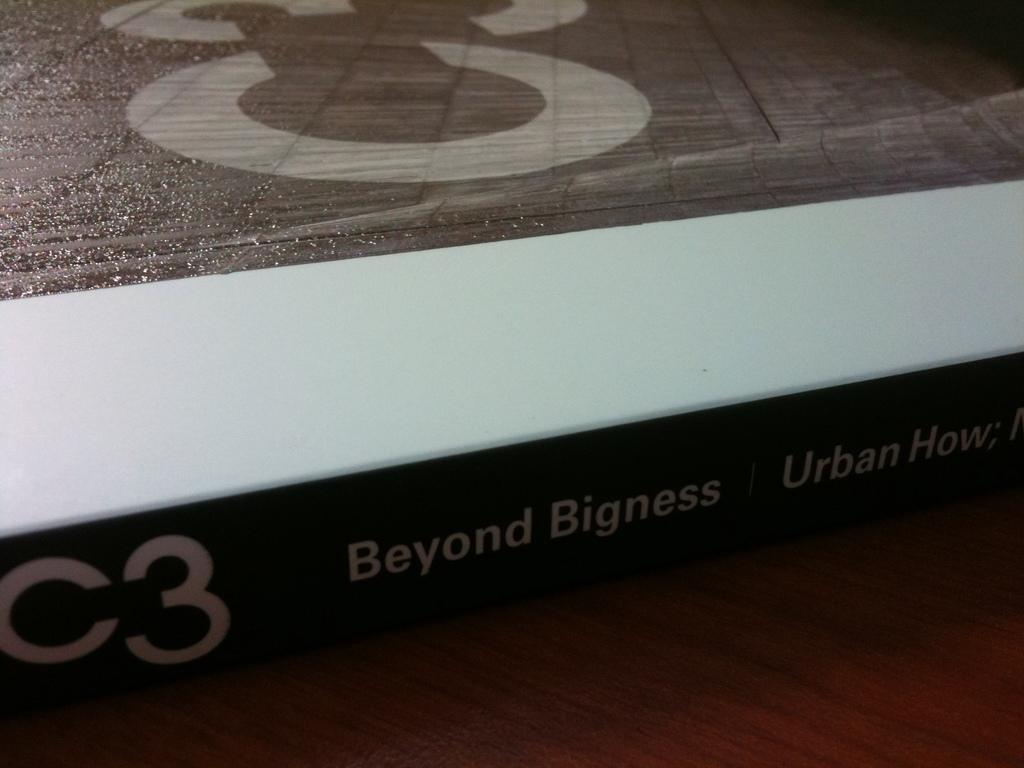<image>
Describe the image concisely. On a wooden table sits a volume called BEYOND BIGNESS. 